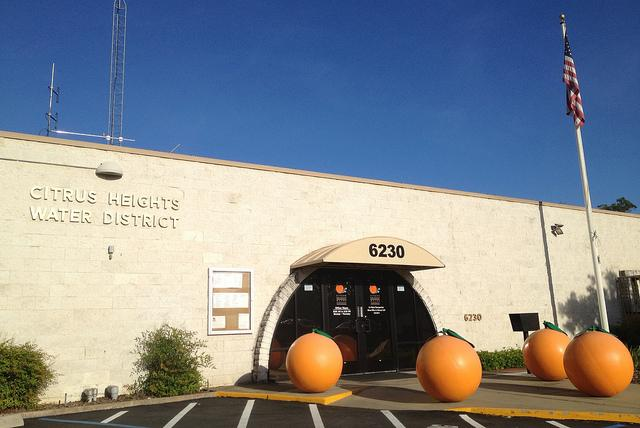What time in the morning does this building open to the public? early 